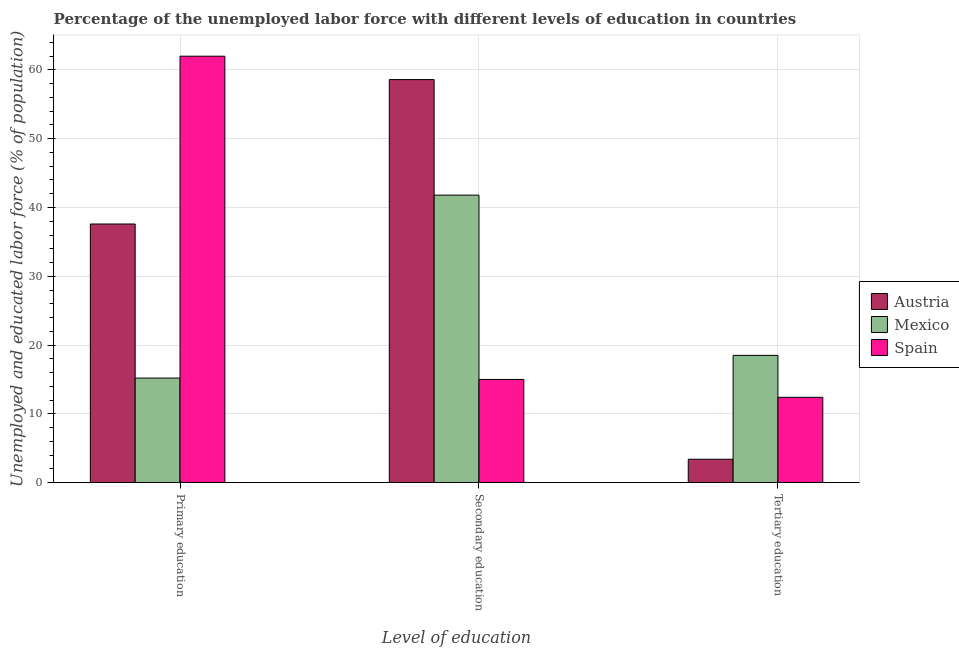How many different coloured bars are there?
Your answer should be very brief. 3. How many groups of bars are there?
Offer a terse response. 3. Are the number of bars per tick equal to the number of legend labels?
Offer a very short reply. Yes. Are the number of bars on each tick of the X-axis equal?
Your response must be concise. Yes. What is the label of the 3rd group of bars from the left?
Your response must be concise. Tertiary education. What is the percentage of labor force who received secondary education in Mexico?
Your answer should be compact. 41.8. Across all countries, what is the maximum percentage of labor force who received primary education?
Provide a succinct answer. 62. Across all countries, what is the minimum percentage of labor force who received primary education?
Provide a short and direct response. 15.2. What is the total percentage of labor force who received tertiary education in the graph?
Provide a short and direct response. 34.3. What is the difference between the percentage of labor force who received tertiary education in Spain and that in Mexico?
Your answer should be compact. -6.1. What is the average percentage of labor force who received secondary education per country?
Make the answer very short. 38.47. What is the ratio of the percentage of labor force who received primary education in Austria to that in Spain?
Your answer should be compact. 0.61. Is the difference between the percentage of labor force who received tertiary education in Mexico and Spain greater than the difference between the percentage of labor force who received primary education in Mexico and Spain?
Offer a very short reply. Yes. What is the difference between the highest and the second highest percentage of labor force who received tertiary education?
Offer a very short reply. 6.1. What is the difference between the highest and the lowest percentage of labor force who received primary education?
Offer a very short reply. 46.8. Is the sum of the percentage of labor force who received secondary education in Mexico and Spain greater than the maximum percentage of labor force who received primary education across all countries?
Ensure brevity in your answer.  No. What is the difference between two consecutive major ticks on the Y-axis?
Give a very brief answer. 10. What is the title of the graph?
Keep it short and to the point. Percentage of the unemployed labor force with different levels of education in countries. Does "East Asia (developing only)" appear as one of the legend labels in the graph?
Keep it short and to the point. No. What is the label or title of the X-axis?
Your response must be concise. Level of education. What is the label or title of the Y-axis?
Give a very brief answer. Unemployed and educated labor force (% of population). What is the Unemployed and educated labor force (% of population) in Austria in Primary education?
Provide a succinct answer. 37.6. What is the Unemployed and educated labor force (% of population) in Mexico in Primary education?
Keep it short and to the point. 15.2. What is the Unemployed and educated labor force (% of population) of Austria in Secondary education?
Provide a succinct answer. 58.6. What is the Unemployed and educated labor force (% of population) in Mexico in Secondary education?
Give a very brief answer. 41.8. What is the Unemployed and educated labor force (% of population) in Austria in Tertiary education?
Offer a terse response. 3.4. What is the Unemployed and educated labor force (% of population) of Spain in Tertiary education?
Offer a very short reply. 12.4. Across all Level of education, what is the maximum Unemployed and educated labor force (% of population) in Austria?
Provide a succinct answer. 58.6. Across all Level of education, what is the maximum Unemployed and educated labor force (% of population) in Mexico?
Your response must be concise. 41.8. Across all Level of education, what is the minimum Unemployed and educated labor force (% of population) of Austria?
Make the answer very short. 3.4. Across all Level of education, what is the minimum Unemployed and educated labor force (% of population) in Mexico?
Offer a very short reply. 15.2. Across all Level of education, what is the minimum Unemployed and educated labor force (% of population) of Spain?
Make the answer very short. 12.4. What is the total Unemployed and educated labor force (% of population) in Austria in the graph?
Your response must be concise. 99.6. What is the total Unemployed and educated labor force (% of population) of Mexico in the graph?
Offer a terse response. 75.5. What is the total Unemployed and educated labor force (% of population) of Spain in the graph?
Your answer should be compact. 89.4. What is the difference between the Unemployed and educated labor force (% of population) of Austria in Primary education and that in Secondary education?
Your response must be concise. -21. What is the difference between the Unemployed and educated labor force (% of population) of Mexico in Primary education and that in Secondary education?
Keep it short and to the point. -26.6. What is the difference between the Unemployed and educated labor force (% of population) of Austria in Primary education and that in Tertiary education?
Offer a very short reply. 34.2. What is the difference between the Unemployed and educated labor force (% of population) of Mexico in Primary education and that in Tertiary education?
Give a very brief answer. -3.3. What is the difference between the Unemployed and educated labor force (% of population) in Spain in Primary education and that in Tertiary education?
Your response must be concise. 49.6. What is the difference between the Unemployed and educated labor force (% of population) in Austria in Secondary education and that in Tertiary education?
Give a very brief answer. 55.2. What is the difference between the Unemployed and educated labor force (% of population) in Mexico in Secondary education and that in Tertiary education?
Provide a short and direct response. 23.3. What is the difference between the Unemployed and educated labor force (% of population) in Spain in Secondary education and that in Tertiary education?
Your answer should be very brief. 2.6. What is the difference between the Unemployed and educated labor force (% of population) of Austria in Primary education and the Unemployed and educated labor force (% of population) of Spain in Secondary education?
Offer a terse response. 22.6. What is the difference between the Unemployed and educated labor force (% of population) of Austria in Primary education and the Unemployed and educated labor force (% of population) of Mexico in Tertiary education?
Give a very brief answer. 19.1. What is the difference between the Unemployed and educated labor force (% of population) in Austria in Primary education and the Unemployed and educated labor force (% of population) in Spain in Tertiary education?
Ensure brevity in your answer.  25.2. What is the difference between the Unemployed and educated labor force (% of population) of Mexico in Primary education and the Unemployed and educated labor force (% of population) of Spain in Tertiary education?
Your answer should be very brief. 2.8. What is the difference between the Unemployed and educated labor force (% of population) of Austria in Secondary education and the Unemployed and educated labor force (% of population) of Mexico in Tertiary education?
Your answer should be compact. 40.1. What is the difference between the Unemployed and educated labor force (% of population) of Austria in Secondary education and the Unemployed and educated labor force (% of population) of Spain in Tertiary education?
Your response must be concise. 46.2. What is the difference between the Unemployed and educated labor force (% of population) of Mexico in Secondary education and the Unemployed and educated labor force (% of population) of Spain in Tertiary education?
Provide a succinct answer. 29.4. What is the average Unemployed and educated labor force (% of population) of Austria per Level of education?
Your answer should be very brief. 33.2. What is the average Unemployed and educated labor force (% of population) of Mexico per Level of education?
Your answer should be very brief. 25.17. What is the average Unemployed and educated labor force (% of population) in Spain per Level of education?
Your answer should be very brief. 29.8. What is the difference between the Unemployed and educated labor force (% of population) of Austria and Unemployed and educated labor force (% of population) of Mexico in Primary education?
Your response must be concise. 22.4. What is the difference between the Unemployed and educated labor force (% of population) of Austria and Unemployed and educated labor force (% of population) of Spain in Primary education?
Give a very brief answer. -24.4. What is the difference between the Unemployed and educated labor force (% of population) in Mexico and Unemployed and educated labor force (% of population) in Spain in Primary education?
Make the answer very short. -46.8. What is the difference between the Unemployed and educated labor force (% of population) of Austria and Unemployed and educated labor force (% of population) of Spain in Secondary education?
Your answer should be compact. 43.6. What is the difference between the Unemployed and educated labor force (% of population) in Mexico and Unemployed and educated labor force (% of population) in Spain in Secondary education?
Make the answer very short. 26.8. What is the difference between the Unemployed and educated labor force (% of population) of Austria and Unemployed and educated labor force (% of population) of Mexico in Tertiary education?
Make the answer very short. -15.1. What is the difference between the Unemployed and educated labor force (% of population) in Austria and Unemployed and educated labor force (% of population) in Spain in Tertiary education?
Your answer should be very brief. -9. What is the ratio of the Unemployed and educated labor force (% of population) in Austria in Primary education to that in Secondary education?
Keep it short and to the point. 0.64. What is the ratio of the Unemployed and educated labor force (% of population) of Mexico in Primary education to that in Secondary education?
Make the answer very short. 0.36. What is the ratio of the Unemployed and educated labor force (% of population) in Spain in Primary education to that in Secondary education?
Offer a terse response. 4.13. What is the ratio of the Unemployed and educated labor force (% of population) in Austria in Primary education to that in Tertiary education?
Offer a very short reply. 11.06. What is the ratio of the Unemployed and educated labor force (% of population) in Mexico in Primary education to that in Tertiary education?
Offer a terse response. 0.82. What is the ratio of the Unemployed and educated labor force (% of population) in Austria in Secondary education to that in Tertiary education?
Provide a succinct answer. 17.24. What is the ratio of the Unemployed and educated labor force (% of population) of Mexico in Secondary education to that in Tertiary education?
Offer a very short reply. 2.26. What is the ratio of the Unemployed and educated labor force (% of population) of Spain in Secondary education to that in Tertiary education?
Your response must be concise. 1.21. What is the difference between the highest and the second highest Unemployed and educated labor force (% of population) of Austria?
Give a very brief answer. 21. What is the difference between the highest and the second highest Unemployed and educated labor force (% of population) of Mexico?
Provide a succinct answer. 23.3. What is the difference between the highest and the second highest Unemployed and educated labor force (% of population) in Spain?
Ensure brevity in your answer.  47. What is the difference between the highest and the lowest Unemployed and educated labor force (% of population) of Austria?
Ensure brevity in your answer.  55.2. What is the difference between the highest and the lowest Unemployed and educated labor force (% of population) in Mexico?
Provide a succinct answer. 26.6. What is the difference between the highest and the lowest Unemployed and educated labor force (% of population) in Spain?
Your answer should be compact. 49.6. 